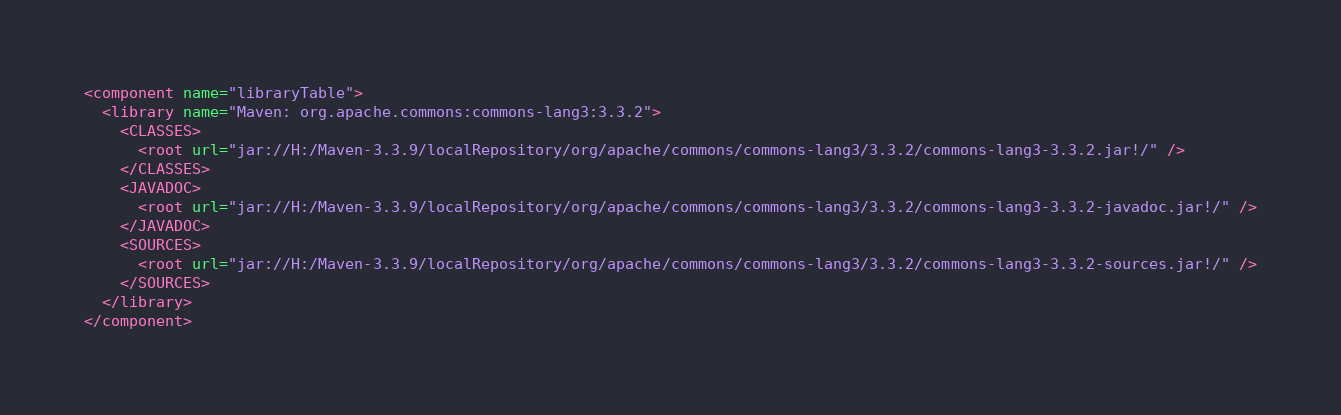Convert code to text. <code><loc_0><loc_0><loc_500><loc_500><_XML_><component name="libraryTable">
  <library name="Maven: org.apache.commons:commons-lang3:3.3.2">
    <CLASSES>
      <root url="jar://H:/Maven-3.3.9/localRepository/org/apache/commons/commons-lang3/3.3.2/commons-lang3-3.3.2.jar!/" />
    </CLASSES>
    <JAVADOC>
      <root url="jar://H:/Maven-3.3.9/localRepository/org/apache/commons/commons-lang3/3.3.2/commons-lang3-3.3.2-javadoc.jar!/" />
    </JAVADOC>
    <SOURCES>
      <root url="jar://H:/Maven-3.3.9/localRepository/org/apache/commons/commons-lang3/3.3.2/commons-lang3-3.3.2-sources.jar!/" />
    </SOURCES>
  </library>
</component></code> 